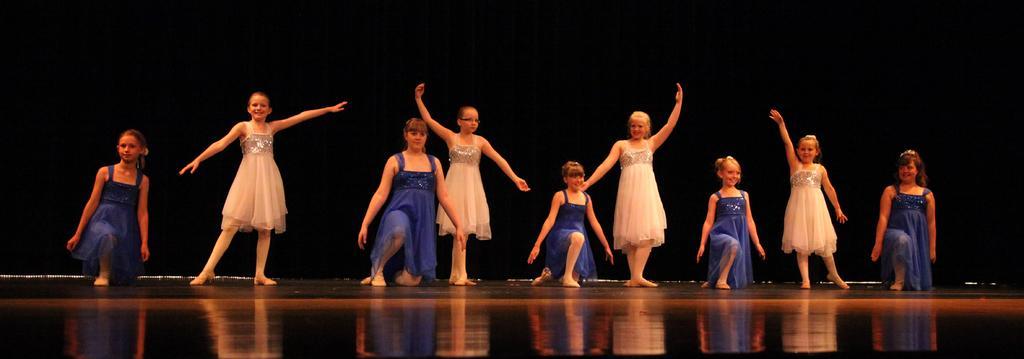Could you give a brief overview of what you see in this image? There are girls in the foreground area of the image, it seems like they are dancing and the background is black. 